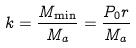<formula> <loc_0><loc_0><loc_500><loc_500>k = \frac { M _ { \min } } { M _ { a } } = \frac { P _ { 0 } r } { M _ { a } }</formula> 